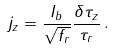Convert formula to latex. <formula><loc_0><loc_0><loc_500><loc_500>j _ { z } = \frac { I _ { b } } { \sqrt { f _ { r } } } \frac { \delta \tau _ { z } } { \tau _ { r } } \, .</formula> 